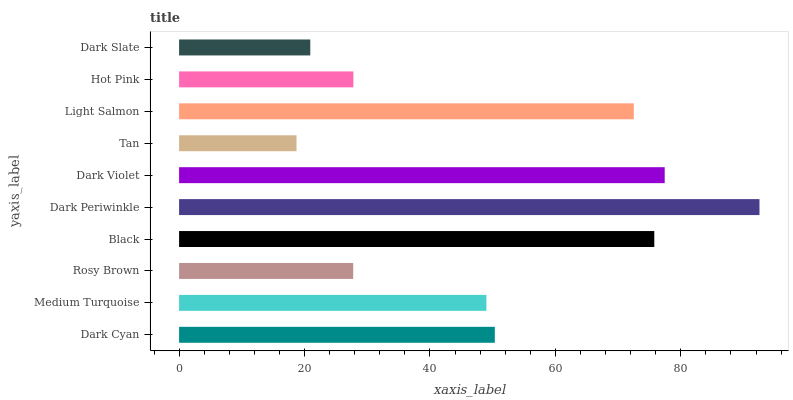Is Tan the minimum?
Answer yes or no. Yes. Is Dark Periwinkle the maximum?
Answer yes or no. Yes. Is Medium Turquoise the minimum?
Answer yes or no. No. Is Medium Turquoise the maximum?
Answer yes or no. No. Is Dark Cyan greater than Medium Turquoise?
Answer yes or no. Yes. Is Medium Turquoise less than Dark Cyan?
Answer yes or no. Yes. Is Medium Turquoise greater than Dark Cyan?
Answer yes or no. No. Is Dark Cyan less than Medium Turquoise?
Answer yes or no. No. Is Dark Cyan the high median?
Answer yes or no. Yes. Is Medium Turquoise the low median?
Answer yes or no. Yes. Is Light Salmon the high median?
Answer yes or no. No. Is Dark Violet the low median?
Answer yes or no. No. 